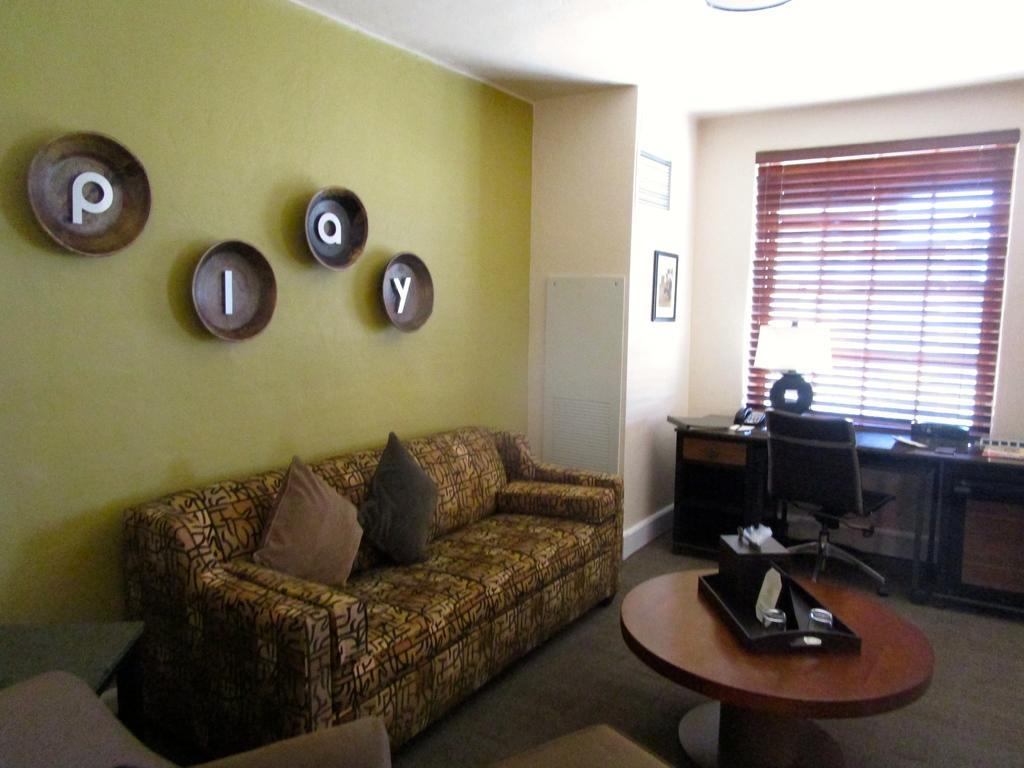Please provide a concise description of this image. This is a picture of a living room where we have couch , 2 pillows, a table , and a stand , table, chair , lamp at the cupboard,window shutter , frame attached to the wall , and 4 alphabet frames attached to the wall. 